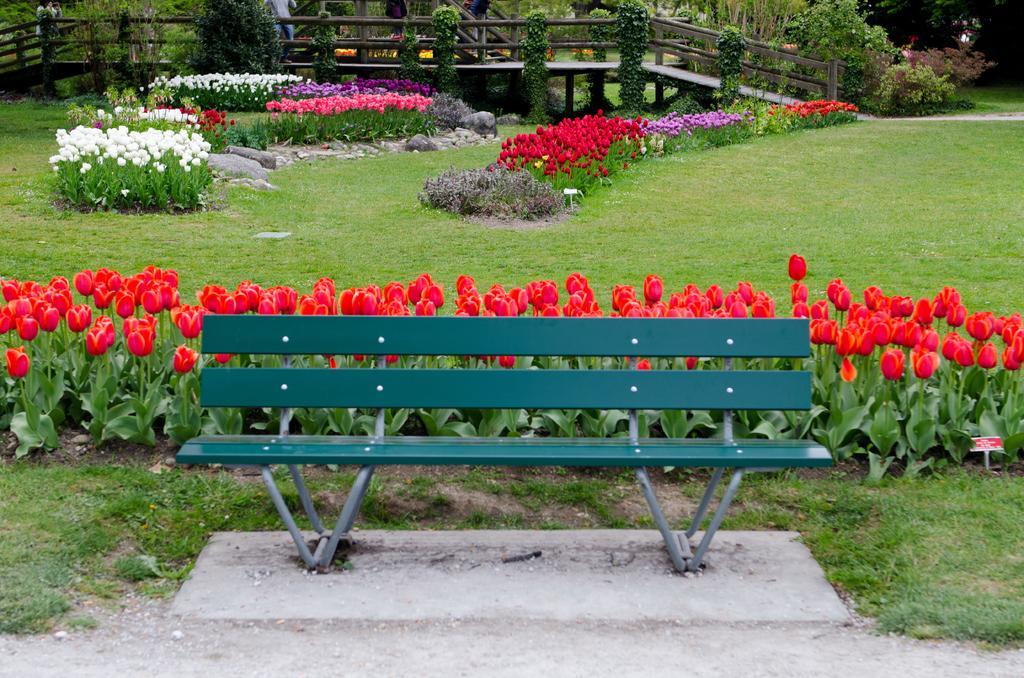How would you summarize this image in a sentence or two? In this picture we can see a bench, plants, flowers, grass and rocks. In the background of the image there are people and we can see railing and trees. 